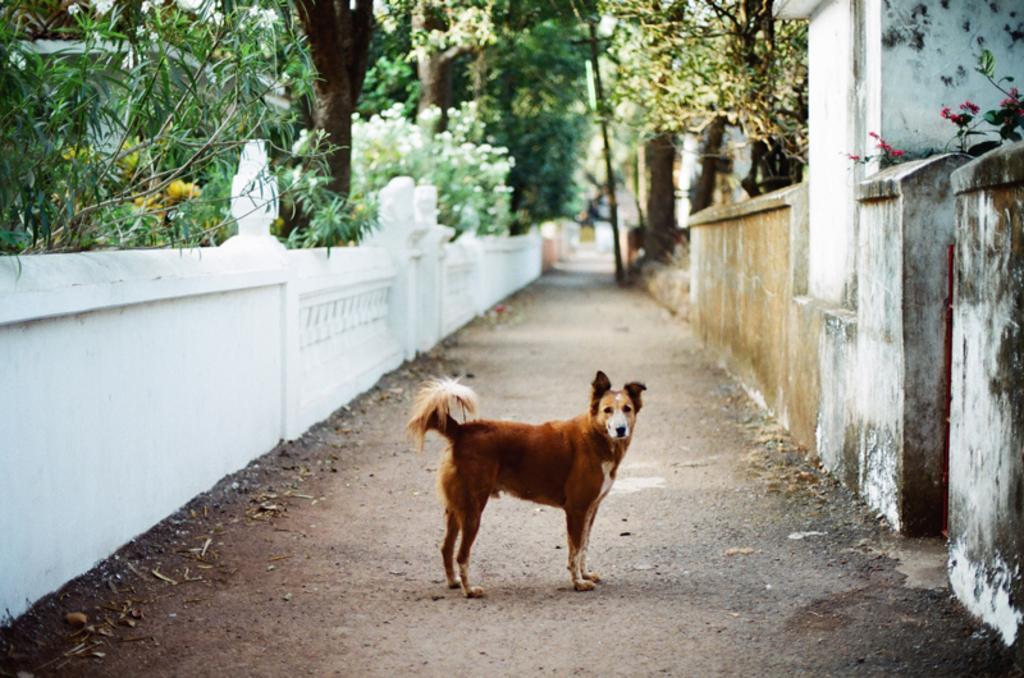Describe this image in one or two sentences. In this image there is a dog standing , and in the background there are trees. 